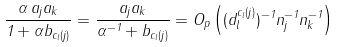<formula> <loc_0><loc_0><loc_500><loc_500>\frac { \alpha \, a _ { j } a _ { k } } { 1 + \alpha b _ { c _ { l } ( j ) } } = \frac { a _ { j } a _ { k } } { \alpha ^ { - 1 } + b _ { c _ { l } ( j ) } } = O _ { p } \left ( ( d ^ { c _ { l } ( j ) } _ { l } ) ^ { - 1 } n _ { j } ^ { - 1 } n _ { k } ^ { - 1 } \right )</formula> 